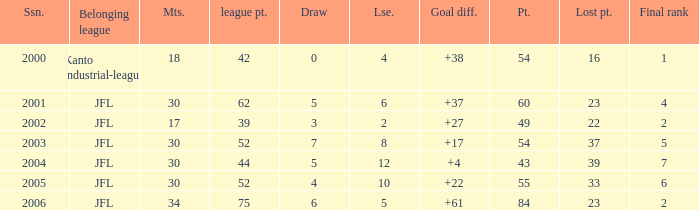Tell me the highest point with lost point being 33 and league point less than 52 None. 